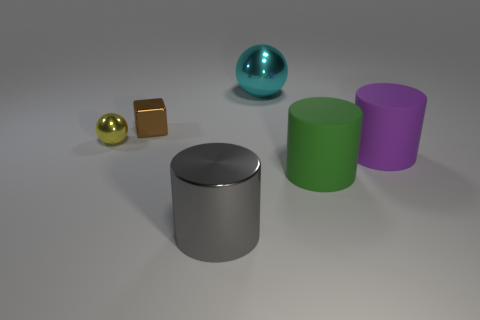There is a big purple object that is the same shape as the large green matte thing; what is its material?
Give a very brief answer. Rubber. Is there any other thing that is made of the same material as the yellow ball?
Offer a terse response. Yes. Is the number of gray cylinders that are behind the brown metal thing greater than the number of green matte objects to the left of the cyan metal thing?
Provide a succinct answer. No. What shape is the cyan object that is made of the same material as the yellow sphere?
Ensure brevity in your answer.  Sphere. What number of other things are there of the same shape as the tiny brown shiny object?
Provide a succinct answer. 0. There is a small object in front of the tiny brown cube; what is its shape?
Give a very brief answer. Sphere. The shiny cube has what color?
Provide a short and direct response. Brown. How many other things are the same size as the purple rubber thing?
Your answer should be compact. 3. What material is the large cylinder that is left of the big shiny object that is on the right side of the large gray shiny cylinder?
Your answer should be compact. Metal. Does the shiny cylinder have the same size as the sphere in front of the cyan object?
Ensure brevity in your answer.  No. 